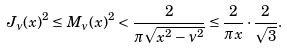Convert formula to latex. <formula><loc_0><loc_0><loc_500><loc_500>J _ { \nu } ( x ) ^ { 2 } \leq M _ { \nu } ( x ) ^ { 2 } < \frac { 2 } { \pi \sqrt { x ^ { 2 } - \nu ^ { 2 } } } \leq \frac { 2 } { \pi x } \cdot \frac { 2 } { \sqrt { 3 } } .</formula> 